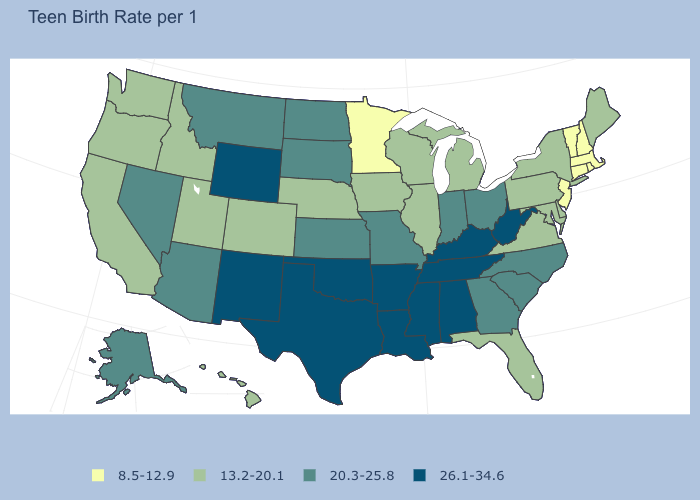What is the lowest value in the USA?
Short answer required. 8.5-12.9. What is the value of New Mexico?
Give a very brief answer. 26.1-34.6. How many symbols are there in the legend?
Short answer required. 4. What is the value of Virginia?
Give a very brief answer. 13.2-20.1. What is the value of Hawaii?
Short answer required. 13.2-20.1. Name the states that have a value in the range 20.3-25.8?
Keep it brief. Alaska, Arizona, Georgia, Indiana, Kansas, Missouri, Montana, Nevada, North Carolina, North Dakota, Ohio, South Carolina, South Dakota. Name the states that have a value in the range 20.3-25.8?
Give a very brief answer. Alaska, Arizona, Georgia, Indiana, Kansas, Missouri, Montana, Nevada, North Carolina, North Dakota, Ohio, South Carolina, South Dakota. Is the legend a continuous bar?
Keep it brief. No. What is the value of Nebraska?
Answer briefly. 13.2-20.1. Name the states that have a value in the range 26.1-34.6?
Give a very brief answer. Alabama, Arkansas, Kentucky, Louisiana, Mississippi, New Mexico, Oklahoma, Tennessee, Texas, West Virginia, Wyoming. What is the lowest value in the MidWest?
Be succinct. 8.5-12.9. Name the states that have a value in the range 13.2-20.1?
Give a very brief answer. California, Colorado, Delaware, Florida, Hawaii, Idaho, Illinois, Iowa, Maine, Maryland, Michigan, Nebraska, New York, Oregon, Pennsylvania, Utah, Virginia, Washington, Wisconsin. What is the value of Michigan?
Give a very brief answer. 13.2-20.1. What is the lowest value in states that border Georgia?
Concise answer only. 13.2-20.1. Does the first symbol in the legend represent the smallest category?
Quick response, please. Yes. 